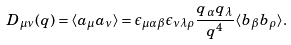<formula> <loc_0><loc_0><loc_500><loc_500>D _ { \mu \nu } ( q ) = \langle a _ { \mu } a _ { \nu } \rangle = \epsilon _ { \mu \alpha \beta } \epsilon _ { \nu \lambda \rho } \frac { q _ { \alpha } q _ { \lambda } } { q ^ { 4 } } \langle b _ { \beta } b _ { \rho } \rangle .</formula> 